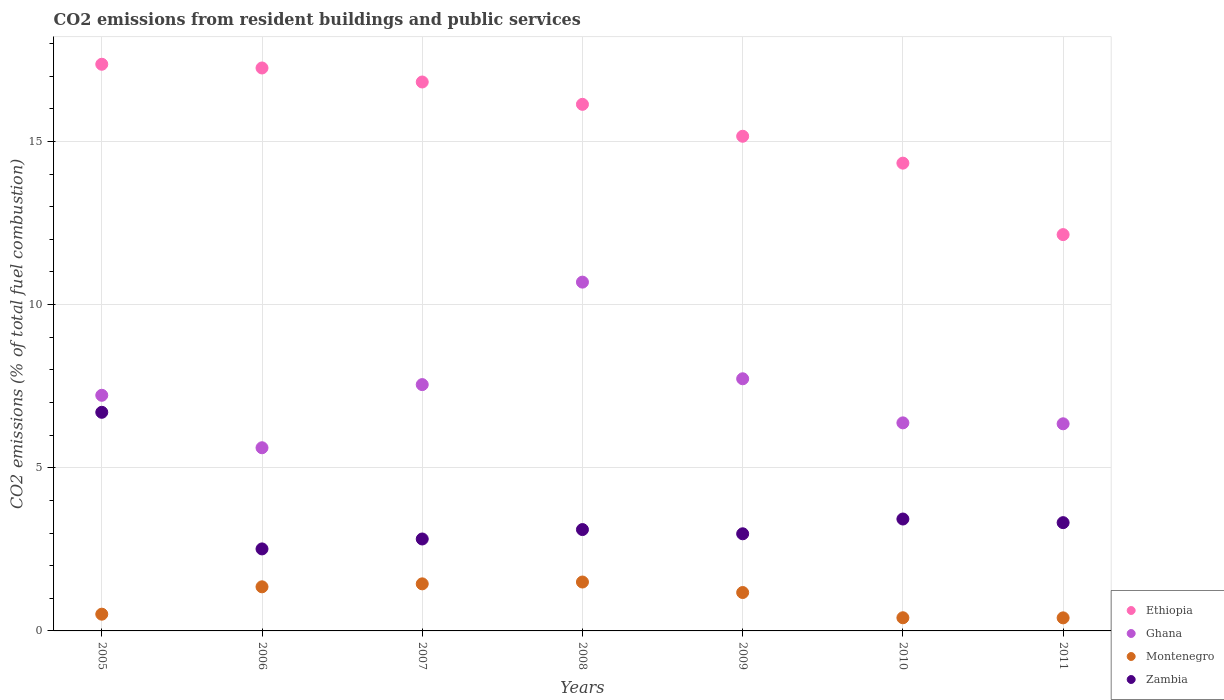How many different coloured dotlines are there?
Make the answer very short. 4. Is the number of dotlines equal to the number of legend labels?
Provide a short and direct response. Yes. What is the total CO2 emitted in Zambia in 2009?
Provide a succinct answer. 2.98. Across all years, what is the maximum total CO2 emitted in Montenegro?
Offer a terse response. 1.5. Across all years, what is the minimum total CO2 emitted in Ethiopia?
Offer a very short reply. 12.14. In which year was the total CO2 emitted in Ethiopia maximum?
Offer a very short reply. 2005. In which year was the total CO2 emitted in Ethiopia minimum?
Your answer should be very brief. 2011. What is the total total CO2 emitted in Ethiopia in the graph?
Give a very brief answer. 109.2. What is the difference between the total CO2 emitted in Ethiopia in 2005 and that in 2010?
Provide a succinct answer. 3.03. What is the difference between the total CO2 emitted in Ghana in 2008 and the total CO2 emitted in Zambia in 2007?
Offer a very short reply. 7.87. What is the average total CO2 emitted in Zambia per year?
Your response must be concise. 3.55. In the year 2007, what is the difference between the total CO2 emitted in Zambia and total CO2 emitted in Ghana?
Your answer should be compact. -4.73. What is the ratio of the total CO2 emitted in Ghana in 2008 to that in 2011?
Your answer should be very brief. 1.68. Is the total CO2 emitted in Ethiopia in 2009 less than that in 2010?
Offer a terse response. No. Is the difference between the total CO2 emitted in Zambia in 2009 and 2010 greater than the difference between the total CO2 emitted in Ghana in 2009 and 2010?
Your response must be concise. No. What is the difference between the highest and the second highest total CO2 emitted in Montenegro?
Give a very brief answer. 0.06. What is the difference between the highest and the lowest total CO2 emitted in Ghana?
Offer a terse response. 5.07. Is the sum of the total CO2 emitted in Ethiopia in 2008 and 2010 greater than the maximum total CO2 emitted in Ghana across all years?
Offer a very short reply. Yes. Is it the case that in every year, the sum of the total CO2 emitted in Zambia and total CO2 emitted in Ethiopia  is greater than the total CO2 emitted in Montenegro?
Give a very brief answer. Yes. Does the total CO2 emitted in Ghana monotonically increase over the years?
Your answer should be compact. No. Is the total CO2 emitted in Ethiopia strictly less than the total CO2 emitted in Zambia over the years?
Make the answer very short. No. How many years are there in the graph?
Keep it short and to the point. 7. Are the values on the major ticks of Y-axis written in scientific E-notation?
Give a very brief answer. No. Does the graph contain grids?
Keep it short and to the point. Yes. How many legend labels are there?
Keep it short and to the point. 4. How are the legend labels stacked?
Give a very brief answer. Vertical. What is the title of the graph?
Give a very brief answer. CO2 emissions from resident buildings and public services. Does "Israel" appear as one of the legend labels in the graph?
Your answer should be compact. No. What is the label or title of the Y-axis?
Keep it short and to the point. CO2 emissions (% of total fuel combustion). What is the CO2 emissions (% of total fuel combustion) in Ethiopia in 2005?
Ensure brevity in your answer.  17.36. What is the CO2 emissions (% of total fuel combustion) in Ghana in 2005?
Provide a succinct answer. 7.22. What is the CO2 emissions (% of total fuel combustion) in Montenegro in 2005?
Make the answer very short. 0.51. What is the CO2 emissions (% of total fuel combustion) in Zambia in 2005?
Ensure brevity in your answer.  6.7. What is the CO2 emissions (% of total fuel combustion) in Ethiopia in 2006?
Offer a terse response. 17.25. What is the CO2 emissions (% of total fuel combustion) in Ghana in 2006?
Make the answer very short. 5.61. What is the CO2 emissions (% of total fuel combustion) of Montenegro in 2006?
Provide a short and direct response. 1.35. What is the CO2 emissions (% of total fuel combustion) in Zambia in 2006?
Your response must be concise. 2.51. What is the CO2 emissions (% of total fuel combustion) of Ethiopia in 2007?
Offer a very short reply. 16.82. What is the CO2 emissions (% of total fuel combustion) in Ghana in 2007?
Your answer should be compact. 7.55. What is the CO2 emissions (% of total fuel combustion) in Montenegro in 2007?
Offer a terse response. 1.44. What is the CO2 emissions (% of total fuel combustion) of Zambia in 2007?
Provide a succinct answer. 2.82. What is the CO2 emissions (% of total fuel combustion) of Ethiopia in 2008?
Give a very brief answer. 16.13. What is the CO2 emissions (% of total fuel combustion) in Ghana in 2008?
Offer a very short reply. 10.69. What is the CO2 emissions (% of total fuel combustion) in Montenegro in 2008?
Give a very brief answer. 1.5. What is the CO2 emissions (% of total fuel combustion) in Zambia in 2008?
Give a very brief answer. 3.11. What is the CO2 emissions (% of total fuel combustion) of Ethiopia in 2009?
Provide a succinct answer. 15.16. What is the CO2 emissions (% of total fuel combustion) of Ghana in 2009?
Your answer should be compact. 7.73. What is the CO2 emissions (% of total fuel combustion) in Montenegro in 2009?
Provide a succinct answer. 1.18. What is the CO2 emissions (% of total fuel combustion) in Zambia in 2009?
Your response must be concise. 2.98. What is the CO2 emissions (% of total fuel combustion) of Ethiopia in 2010?
Keep it short and to the point. 14.33. What is the CO2 emissions (% of total fuel combustion) of Ghana in 2010?
Keep it short and to the point. 6.37. What is the CO2 emissions (% of total fuel combustion) in Montenegro in 2010?
Keep it short and to the point. 0.4. What is the CO2 emissions (% of total fuel combustion) in Zambia in 2010?
Offer a very short reply. 3.43. What is the CO2 emissions (% of total fuel combustion) of Ethiopia in 2011?
Your answer should be very brief. 12.14. What is the CO2 emissions (% of total fuel combustion) in Ghana in 2011?
Offer a terse response. 6.35. What is the CO2 emissions (% of total fuel combustion) of Zambia in 2011?
Offer a terse response. 3.32. Across all years, what is the maximum CO2 emissions (% of total fuel combustion) of Ethiopia?
Your answer should be compact. 17.36. Across all years, what is the maximum CO2 emissions (% of total fuel combustion) in Ghana?
Your answer should be very brief. 10.69. Across all years, what is the maximum CO2 emissions (% of total fuel combustion) of Montenegro?
Make the answer very short. 1.5. Across all years, what is the maximum CO2 emissions (% of total fuel combustion) in Zambia?
Provide a succinct answer. 6.7. Across all years, what is the minimum CO2 emissions (% of total fuel combustion) in Ethiopia?
Your answer should be compact. 12.14. Across all years, what is the minimum CO2 emissions (% of total fuel combustion) in Ghana?
Your answer should be very brief. 5.61. Across all years, what is the minimum CO2 emissions (% of total fuel combustion) of Montenegro?
Offer a terse response. 0.4. Across all years, what is the minimum CO2 emissions (% of total fuel combustion) of Zambia?
Offer a terse response. 2.51. What is the total CO2 emissions (% of total fuel combustion) in Ethiopia in the graph?
Your answer should be compact. 109.2. What is the total CO2 emissions (% of total fuel combustion) of Ghana in the graph?
Provide a short and direct response. 51.51. What is the total CO2 emissions (% of total fuel combustion) in Montenegro in the graph?
Your answer should be compact. 6.78. What is the total CO2 emissions (% of total fuel combustion) in Zambia in the graph?
Your response must be concise. 24.86. What is the difference between the CO2 emissions (% of total fuel combustion) of Ethiopia in 2005 and that in 2006?
Provide a short and direct response. 0.11. What is the difference between the CO2 emissions (% of total fuel combustion) of Ghana in 2005 and that in 2006?
Ensure brevity in your answer.  1.61. What is the difference between the CO2 emissions (% of total fuel combustion) of Montenegro in 2005 and that in 2006?
Make the answer very short. -0.84. What is the difference between the CO2 emissions (% of total fuel combustion) in Zambia in 2005 and that in 2006?
Offer a terse response. 4.19. What is the difference between the CO2 emissions (% of total fuel combustion) of Ethiopia in 2005 and that in 2007?
Your response must be concise. 0.54. What is the difference between the CO2 emissions (% of total fuel combustion) of Ghana in 2005 and that in 2007?
Give a very brief answer. -0.33. What is the difference between the CO2 emissions (% of total fuel combustion) in Montenegro in 2005 and that in 2007?
Provide a short and direct response. -0.93. What is the difference between the CO2 emissions (% of total fuel combustion) in Zambia in 2005 and that in 2007?
Provide a short and direct response. 3.88. What is the difference between the CO2 emissions (% of total fuel combustion) in Ethiopia in 2005 and that in 2008?
Your answer should be very brief. 1.23. What is the difference between the CO2 emissions (% of total fuel combustion) in Ghana in 2005 and that in 2008?
Your answer should be compact. -3.47. What is the difference between the CO2 emissions (% of total fuel combustion) of Montenegro in 2005 and that in 2008?
Your answer should be very brief. -0.99. What is the difference between the CO2 emissions (% of total fuel combustion) in Zambia in 2005 and that in 2008?
Offer a terse response. 3.59. What is the difference between the CO2 emissions (% of total fuel combustion) of Ethiopia in 2005 and that in 2009?
Your response must be concise. 2.21. What is the difference between the CO2 emissions (% of total fuel combustion) of Ghana in 2005 and that in 2009?
Ensure brevity in your answer.  -0.51. What is the difference between the CO2 emissions (% of total fuel combustion) of Montenegro in 2005 and that in 2009?
Provide a succinct answer. -0.66. What is the difference between the CO2 emissions (% of total fuel combustion) of Zambia in 2005 and that in 2009?
Provide a short and direct response. 3.72. What is the difference between the CO2 emissions (% of total fuel combustion) in Ethiopia in 2005 and that in 2010?
Give a very brief answer. 3.03. What is the difference between the CO2 emissions (% of total fuel combustion) of Ghana in 2005 and that in 2010?
Your response must be concise. 0.84. What is the difference between the CO2 emissions (% of total fuel combustion) in Montenegro in 2005 and that in 2010?
Offer a terse response. 0.11. What is the difference between the CO2 emissions (% of total fuel combustion) of Zambia in 2005 and that in 2010?
Provide a short and direct response. 3.27. What is the difference between the CO2 emissions (% of total fuel combustion) in Ethiopia in 2005 and that in 2011?
Provide a short and direct response. 5.22. What is the difference between the CO2 emissions (% of total fuel combustion) of Ghana in 2005 and that in 2011?
Your answer should be very brief. 0.87. What is the difference between the CO2 emissions (% of total fuel combustion) in Montenegro in 2005 and that in 2011?
Ensure brevity in your answer.  0.11. What is the difference between the CO2 emissions (% of total fuel combustion) of Zambia in 2005 and that in 2011?
Offer a terse response. 3.38. What is the difference between the CO2 emissions (% of total fuel combustion) of Ethiopia in 2006 and that in 2007?
Make the answer very short. 0.43. What is the difference between the CO2 emissions (% of total fuel combustion) in Ghana in 2006 and that in 2007?
Provide a short and direct response. -1.93. What is the difference between the CO2 emissions (% of total fuel combustion) in Montenegro in 2006 and that in 2007?
Provide a short and direct response. -0.09. What is the difference between the CO2 emissions (% of total fuel combustion) in Zambia in 2006 and that in 2007?
Your answer should be compact. -0.3. What is the difference between the CO2 emissions (% of total fuel combustion) of Ethiopia in 2006 and that in 2008?
Ensure brevity in your answer.  1.11. What is the difference between the CO2 emissions (% of total fuel combustion) in Ghana in 2006 and that in 2008?
Offer a very short reply. -5.07. What is the difference between the CO2 emissions (% of total fuel combustion) of Montenegro in 2006 and that in 2008?
Give a very brief answer. -0.15. What is the difference between the CO2 emissions (% of total fuel combustion) of Zambia in 2006 and that in 2008?
Ensure brevity in your answer.  -0.59. What is the difference between the CO2 emissions (% of total fuel combustion) of Ethiopia in 2006 and that in 2009?
Give a very brief answer. 2.09. What is the difference between the CO2 emissions (% of total fuel combustion) in Ghana in 2006 and that in 2009?
Your response must be concise. -2.11. What is the difference between the CO2 emissions (% of total fuel combustion) of Montenegro in 2006 and that in 2009?
Keep it short and to the point. 0.17. What is the difference between the CO2 emissions (% of total fuel combustion) in Zambia in 2006 and that in 2009?
Ensure brevity in your answer.  -0.46. What is the difference between the CO2 emissions (% of total fuel combustion) in Ethiopia in 2006 and that in 2010?
Keep it short and to the point. 2.92. What is the difference between the CO2 emissions (% of total fuel combustion) in Ghana in 2006 and that in 2010?
Your answer should be very brief. -0.76. What is the difference between the CO2 emissions (% of total fuel combustion) of Montenegro in 2006 and that in 2010?
Make the answer very short. 0.95. What is the difference between the CO2 emissions (% of total fuel combustion) of Zambia in 2006 and that in 2010?
Offer a very short reply. -0.92. What is the difference between the CO2 emissions (% of total fuel combustion) of Ethiopia in 2006 and that in 2011?
Make the answer very short. 5.11. What is the difference between the CO2 emissions (% of total fuel combustion) of Ghana in 2006 and that in 2011?
Offer a terse response. -0.73. What is the difference between the CO2 emissions (% of total fuel combustion) of Montenegro in 2006 and that in 2011?
Give a very brief answer. 0.95. What is the difference between the CO2 emissions (% of total fuel combustion) of Zambia in 2006 and that in 2011?
Give a very brief answer. -0.81. What is the difference between the CO2 emissions (% of total fuel combustion) in Ethiopia in 2007 and that in 2008?
Ensure brevity in your answer.  0.68. What is the difference between the CO2 emissions (% of total fuel combustion) in Ghana in 2007 and that in 2008?
Give a very brief answer. -3.14. What is the difference between the CO2 emissions (% of total fuel combustion) in Montenegro in 2007 and that in 2008?
Keep it short and to the point. -0.06. What is the difference between the CO2 emissions (% of total fuel combustion) in Zambia in 2007 and that in 2008?
Provide a short and direct response. -0.29. What is the difference between the CO2 emissions (% of total fuel combustion) of Ethiopia in 2007 and that in 2009?
Give a very brief answer. 1.66. What is the difference between the CO2 emissions (% of total fuel combustion) in Ghana in 2007 and that in 2009?
Your response must be concise. -0.18. What is the difference between the CO2 emissions (% of total fuel combustion) of Montenegro in 2007 and that in 2009?
Ensure brevity in your answer.  0.27. What is the difference between the CO2 emissions (% of total fuel combustion) in Zambia in 2007 and that in 2009?
Keep it short and to the point. -0.16. What is the difference between the CO2 emissions (% of total fuel combustion) in Ethiopia in 2007 and that in 2010?
Give a very brief answer. 2.49. What is the difference between the CO2 emissions (% of total fuel combustion) of Ghana in 2007 and that in 2010?
Offer a very short reply. 1.17. What is the difference between the CO2 emissions (% of total fuel combustion) of Montenegro in 2007 and that in 2010?
Offer a very short reply. 1.04. What is the difference between the CO2 emissions (% of total fuel combustion) of Zambia in 2007 and that in 2010?
Keep it short and to the point. -0.61. What is the difference between the CO2 emissions (% of total fuel combustion) in Ethiopia in 2007 and that in 2011?
Offer a very short reply. 4.68. What is the difference between the CO2 emissions (% of total fuel combustion) of Ghana in 2007 and that in 2011?
Your response must be concise. 1.2. What is the difference between the CO2 emissions (% of total fuel combustion) of Montenegro in 2007 and that in 2011?
Your response must be concise. 1.04. What is the difference between the CO2 emissions (% of total fuel combustion) in Zambia in 2007 and that in 2011?
Ensure brevity in your answer.  -0.5. What is the difference between the CO2 emissions (% of total fuel combustion) in Ethiopia in 2008 and that in 2009?
Your response must be concise. 0.98. What is the difference between the CO2 emissions (% of total fuel combustion) in Ghana in 2008 and that in 2009?
Your response must be concise. 2.96. What is the difference between the CO2 emissions (% of total fuel combustion) in Montenegro in 2008 and that in 2009?
Your response must be concise. 0.32. What is the difference between the CO2 emissions (% of total fuel combustion) of Zambia in 2008 and that in 2009?
Your answer should be compact. 0.13. What is the difference between the CO2 emissions (% of total fuel combustion) of Ethiopia in 2008 and that in 2010?
Offer a very short reply. 1.8. What is the difference between the CO2 emissions (% of total fuel combustion) in Ghana in 2008 and that in 2010?
Offer a terse response. 4.31. What is the difference between the CO2 emissions (% of total fuel combustion) of Montenegro in 2008 and that in 2010?
Offer a terse response. 1.09. What is the difference between the CO2 emissions (% of total fuel combustion) in Zambia in 2008 and that in 2010?
Your response must be concise. -0.32. What is the difference between the CO2 emissions (% of total fuel combustion) in Ethiopia in 2008 and that in 2011?
Offer a terse response. 3.99. What is the difference between the CO2 emissions (% of total fuel combustion) in Ghana in 2008 and that in 2011?
Your answer should be very brief. 4.34. What is the difference between the CO2 emissions (% of total fuel combustion) of Montenegro in 2008 and that in 2011?
Your answer should be compact. 1.1. What is the difference between the CO2 emissions (% of total fuel combustion) in Zambia in 2008 and that in 2011?
Provide a succinct answer. -0.21. What is the difference between the CO2 emissions (% of total fuel combustion) of Ethiopia in 2009 and that in 2010?
Your answer should be very brief. 0.82. What is the difference between the CO2 emissions (% of total fuel combustion) in Ghana in 2009 and that in 2010?
Your answer should be compact. 1.35. What is the difference between the CO2 emissions (% of total fuel combustion) of Montenegro in 2009 and that in 2010?
Offer a terse response. 0.77. What is the difference between the CO2 emissions (% of total fuel combustion) in Zambia in 2009 and that in 2010?
Give a very brief answer. -0.45. What is the difference between the CO2 emissions (% of total fuel combustion) of Ethiopia in 2009 and that in 2011?
Provide a succinct answer. 3.01. What is the difference between the CO2 emissions (% of total fuel combustion) of Ghana in 2009 and that in 2011?
Your answer should be compact. 1.38. What is the difference between the CO2 emissions (% of total fuel combustion) in Montenegro in 2009 and that in 2011?
Offer a terse response. 0.78. What is the difference between the CO2 emissions (% of total fuel combustion) of Zambia in 2009 and that in 2011?
Keep it short and to the point. -0.34. What is the difference between the CO2 emissions (% of total fuel combustion) of Ethiopia in 2010 and that in 2011?
Offer a very short reply. 2.19. What is the difference between the CO2 emissions (% of total fuel combustion) in Ghana in 2010 and that in 2011?
Make the answer very short. 0.03. What is the difference between the CO2 emissions (% of total fuel combustion) in Montenegro in 2010 and that in 2011?
Offer a very short reply. 0. What is the difference between the CO2 emissions (% of total fuel combustion) in Zambia in 2010 and that in 2011?
Give a very brief answer. 0.11. What is the difference between the CO2 emissions (% of total fuel combustion) in Ethiopia in 2005 and the CO2 emissions (% of total fuel combustion) in Ghana in 2006?
Offer a terse response. 11.75. What is the difference between the CO2 emissions (% of total fuel combustion) in Ethiopia in 2005 and the CO2 emissions (% of total fuel combustion) in Montenegro in 2006?
Offer a terse response. 16.01. What is the difference between the CO2 emissions (% of total fuel combustion) in Ethiopia in 2005 and the CO2 emissions (% of total fuel combustion) in Zambia in 2006?
Offer a terse response. 14.85. What is the difference between the CO2 emissions (% of total fuel combustion) of Ghana in 2005 and the CO2 emissions (% of total fuel combustion) of Montenegro in 2006?
Provide a succinct answer. 5.87. What is the difference between the CO2 emissions (% of total fuel combustion) of Ghana in 2005 and the CO2 emissions (% of total fuel combustion) of Zambia in 2006?
Offer a terse response. 4.71. What is the difference between the CO2 emissions (% of total fuel combustion) in Montenegro in 2005 and the CO2 emissions (% of total fuel combustion) in Zambia in 2006?
Give a very brief answer. -2. What is the difference between the CO2 emissions (% of total fuel combustion) of Ethiopia in 2005 and the CO2 emissions (% of total fuel combustion) of Ghana in 2007?
Offer a very short reply. 9.82. What is the difference between the CO2 emissions (% of total fuel combustion) of Ethiopia in 2005 and the CO2 emissions (% of total fuel combustion) of Montenegro in 2007?
Offer a terse response. 15.92. What is the difference between the CO2 emissions (% of total fuel combustion) in Ethiopia in 2005 and the CO2 emissions (% of total fuel combustion) in Zambia in 2007?
Your answer should be compact. 14.55. What is the difference between the CO2 emissions (% of total fuel combustion) in Ghana in 2005 and the CO2 emissions (% of total fuel combustion) in Montenegro in 2007?
Your answer should be compact. 5.78. What is the difference between the CO2 emissions (% of total fuel combustion) in Ghana in 2005 and the CO2 emissions (% of total fuel combustion) in Zambia in 2007?
Provide a short and direct response. 4.4. What is the difference between the CO2 emissions (% of total fuel combustion) in Montenegro in 2005 and the CO2 emissions (% of total fuel combustion) in Zambia in 2007?
Your answer should be compact. -2.3. What is the difference between the CO2 emissions (% of total fuel combustion) in Ethiopia in 2005 and the CO2 emissions (% of total fuel combustion) in Ghana in 2008?
Offer a terse response. 6.68. What is the difference between the CO2 emissions (% of total fuel combustion) of Ethiopia in 2005 and the CO2 emissions (% of total fuel combustion) of Montenegro in 2008?
Offer a terse response. 15.86. What is the difference between the CO2 emissions (% of total fuel combustion) in Ethiopia in 2005 and the CO2 emissions (% of total fuel combustion) in Zambia in 2008?
Keep it short and to the point. 14.26. What is the difference between the CO2 emissions (% of total fuel combustion) in Ghana in 2005 and the CO2 emissions (% of total fuel combustion) in Montenegro in 2008?
Offer a very short reply. 5.72. What is the difference between the CO2 emissions (% of total fuel combustion) of Ghana in 2005 and the CO2 emissions (% of total fuel combustion) of Zambia in 2008?
Your answer should be compact. 4.11. What is the difference between the CO2 emissions (% of total fuel combustion) in Montenegro in 2005 and the CO2 emissions (% of total fuel combustion) in Zambia in 2008?
Offer a terse response. -2.59. What is the difference between the CO2 emissions (% of total fuel combustion) in Ethiopia in 2005 and the CO2 emissions (% of total fuel combustion) in Ghana in 2009?
Your response must be concise. 9.64. What is the difference between the CO2 emissions (% of total fuel combustion) in Ethiopia in 2005 and the CO2 emissions (% of total fuel combustion) in Montenegro in 2009?
Your answer should be very brief. 16.19. What is the difference between the CO2 emissions (% of total fuel combustion) in Ethiopia in 2005 and the CO2 emissions (% of total fuel combustion) in Zambia in 2009?
Offer a terse response. 14.39. What is the difference between the CO2 emissions (% of total fuel combustion) of Ghana in 2005 and the CO2 emissions (% of total fuel combustion) of Montenegro in 2009?
Your response must be concise. 6.04. What is the difference between the CO2 emissions (% of total fuel combustion) in Ghana in 2005 and the CO2 emissions (% of total fuel combustion) in Zambia in 2009?
Provide a short and direct response. 4.24. What is the difference between the CO2 emissions (% of total fuel combustion) in Montenegro in 2005 and the CO2 emissions (% of total fuel combustion) in Zambia in 2009?
Provide a succinct answer. -2.46. What is the difference between the CO2 emissions (% of total fuel combustion) in Ethiopia in 2005 and the CO2 emissions (% of total fuel combustion) in Ghana in 2010?
Offer a very short reply. 10.99. What is the difference between the CO2 emissions (% of total fuel combustion) of Ethiopia in 2005 and the CO2 emissions (% of total fuel combustion) of Montenegro in 2010?
Provide a succinct answer. 16.96. What is the difference between the CO2 emissions (% of total fuel combustion) in Ethiopia in 2005 and the CO2 emissions (% of total fuel combustion) in Zambia in 2010?
Make the answer very short. 13.93. What is the difference between the CO2 emissions (% of total fuel combustion) in Ghana in 2005 and the CO2 emissions (% of total fuel combustion) in Montenegro in 2010?
Offer a terse response. 6.82. What is the difference between the CO2 emissions (% of total fuel combustion) of Ghana in 2005 and the CO2 emissions (% of total fuel combustion) of Zambia in 2010?
Offer a very short reply. 3.79. What is the difference between the CO2 emissions (% of total fuel combustion) in Montenegro in 2005 and the CO2 emissions (% of total fuel combustion) in Zambia in 2010?
Offer a terse response. -2.92. What is the difference between the CO2 emissions (% of total fuel combustion) in Ethiopia in 2005 and the CO2 emissions (% of total fuel combustion) in Ghana in 2011?
Your answer should be very brief. 11.02. What is the difference between the CO2 emissions (% of total fuel combustion) in Ethiopia in 2005 and the CO2 emissions (% of total fuel combustion) in Montenegro in 2011?
Provide a short and direct response. 16.96. What is the difference between the CO2 emissions (% of total fuel combustion) in Ethiopia in 2005 and the CO2 emissions (% of total fuel combustion) in Zambia in 2011?
Make the answer very short. 14.05. What is the difference between the CO2 emissions (% of total fuel combustion) in Ghana in 2005 and the CO2 emissions (% of total fuel combustion) in Montenegro in 2011?
Make the answer very short. 6.82. What is the difference between the CO2 emissions (% of total fuel combustion) in Ghana in 2005 and the CO2 emissions (% of total fuel combustion) in Zambia in 2011?
Your response must be concise. 3.9. What is the difference between the CO2 emissions (% of total fuel combustion) in Montenegro in 2005 and the CO2 emissions (% of total fuel combustion) in Zambia in 2011?
Ensure brevity in your answer.  -2.8. What is the difference between the CO2 emissions (% of total fuel combustion) of Ethiopia in 2006 and the CO2 emissions (% of total fuel combustion) of Ghana in 2007?
Offer a very short reply. 9.7. What is the difference between the CO2 emissions (% of total fuel combustion) in Ethiopia in 2006 and the CO2 emissions (% of total fuel combustion) in Montenegro in 2007?
Keep it short and to the point. 15.81. What is the difference between the CO2 emissions (% of total fuel combustion) of Ethiopia in 2006 and the CO2 emissions (% of total fuel combustion) of Zambia in 2007?
Keep it short and to the point. 14.43. What is the difference between the CO2 emissions (% of total fuel combustion) in Ghana in 2006 and the CO2 emissions (% of total fuel combustion) in Montenegro in 2007?
Ensure brevity in your answer.  4.17. What is the difference between the CO2 emissions (% of total fuel combustion) of Ghana in 2006 and the CO2 emissions (% of total fuel combustion) of Zambia in 2007?
Keep it short and to the point. 2.8. What is the difference between the CO2 emissions (% of total fuel combustion) of Montenegro in 2006 and the CO2 emissions (% of total fuel combustion) of Zambia in 2007?
Your response must be concise. -1.47. What is the difference between the CO2 emissions (% of total fuel combustion) of Ethiopia in 2006 and the CO2 emissions (% of total fuel combustion) of Ghana in 2008?
Offer a very short reply. 6.56. What is the difference between the CO2 emissions (% of total fuel combustion) of Ethiopia in 2006 and the CO2 emissions (% of total fuel combustion) of Montenegro in 2008?
Keep it short and to the point. 15.75. What is the difference between the CO2 emissions (% of total fuel combustion) of Ethiopia in 2006 and the CO2 emissions (% of total fuel combustion) of Zambia in 2008?
Ensure brevity in your answer.  14.14. What is the difference between the CO2 emissions (% of total fuel combustion) of Ghana in 2006 and the CO2 emissions (% of total fuel combustion) of Montenegro in 2008?
Your answer should be very brief. 4.11. What is the difference between the CO2 emissions (% of total fuel combustion) of Ghana in 2006 and the CO2 emissions (% of total fuel combustion) of Zambia in 2008?
Your answer should be compact. 2.51. What is the difference between the CO2 emissions (% of total fuel combustion) in Montenegro in 2006 and the CO2 emissions (% of total fuel combustion) in Zambia in 2008?
Make the answer very short. -1.75. What is the difference between the CO2 emissions (% of total fuel combustion) of Ethiopia in 2006 and the CO2 emissions (% of total fuel combustion) of Ghana in 2009?
Offer a very short reply. 9.52. What is the difference between the CO2 emissions (% of total fuel combustion) in Ethiopia in 2006 and the CO2 emissions (% of total fuel combustion) in Montenegro in 2009?
Keep it short and to the point. 16.07. What is the difference between the CO2 emissions (% of total fuel combustion) of Ethiopia in 2006 and the CO2 emissions (% of total fuel combustion) of Zambia in 2009?
Give a very brief answer. 14.27. What is the difference between the CO2 emissions (% of total fuel combustion) in Ghana in 2006 and the CO2 emissions (% of total fuel combustion) in Montenegro in 2009?
Ensure brevity in your answer.  4.44. What is the difference between the CO2 emissions (% of total fuel combustion) in Ghana in 2006 and the CO2 emissions (% of total fuel combustion) in Zambia in 2009?
Provide a short and direct response. 2.64. What is the difference between the CO2 emissions (% of total fuel combustion) of Montenegro in 2006 and the CO2 emissions (% of total fuel combustion) of Zambia in 2009?
Provide a short and direct response. -1.62. What is the difference between the CO2 emissions (% of total fuel combustion) of Ethiopia in 2006 and the CO2 emissions (% of total fuel combustion) of Ghana in 2010?
Your answer should be compact. 10.87. What is the difference between the CO2 emissions (% of total fuel combustion) of Ethiopia in 2006 and the CO2 emissions (% of total fuel combustion) of Montenegro in 2010?
Ensure brevity in your answer.  16.85. What is the difference between the CO2 emissions (% of total fuel combustion) of Ethiopia in 2006 and the CO2 emissions (% of total fuel combustion) of Zambia in 2010?
Provide a short and direct response. 13.82. What is the difference between the CO2 emissions (% of total fuel combustion) in Ghana in 2006 and the CO2 emissions (% of total fuel combustion) in Montenegro in 2010?
Provide a short and direct response. 5.21. What is the difference between the CO2 emissions (% of total fuel combustion) in Ghana in 2006 and the CO2 emissions (% of total fuel combustion) in Zambia in 2010?
Your response must be concise. 2.18. What is the difference between the CO2 emissions (% of total fuel combustion) in Montenegro in 2006 and the CO2 emissions (% of total fuel combustion) in Zambia in 2010?
Your answer should be very brief. -2.08. What is the difference between the CO2 emissions (% of total fuel combustion) of Ethiopia in 2006 and the CO2 emissions (% of total fuel combustion) of Ghana in 2011?
Provide a short and direct response. 10.9. What is the difference between the CO2 emissions (% of total fuel combustion) of Ethiopia in 2006 and the CO2 emissions (% of total fuel combustion) of Montenegro in 2011?
Offer a very short reply. 16.85. What is the difference between the CO2 emissions (% of total fuel combustion) of Ethiopia in 2006 and the CO2 emissions (% of total fuel combustion) of Zambia in 2011?
Provide a short and direct response. 13.93. What is the difference between the CO2 emissions (% of total fuel combustion) of Ghana in 2006 and the CO2 emissions (% of total fuel combustion) of Montenegro in 2011?
Your answer should be very brief. 5.21. What is the difference between the CO2 emissions (% of total fuel combustion) of Ghana in 2006 and the CO2 emissions (% of total fuel combustion) of Zambia in 2011?
Give a very brief answer. 2.29. What is the difference between the CO2 emissions (% of total fuel combustion) of Montenegro in 2006 and the CO2 emissions (% of total fuel combustion) of Zambia in 2011?
Ensure brevity in your answer.  -1.97. What is the difference between the CO2 emissions (% of total fuel combustion) in Ethiopia in 2007 and the CO2 emissions (% of total fuel combustion) in Ghana in 2008?
Your answer should be very brief. 6.13. What is the difference between the CO2 emissions (% of total fuel combustion) in Ethiopia in 2007 and the CO2 emissions (% of total fuel combustion) in Montenegro in 2008?
Your answer should be very brief. 15.32. What is the difference between the CO2 emissions (% of total fuel combustion) in Ethiopia in 2007 and the CO2 emissions (% of total fuel combustion) in Zambia in 2008?
Your answer should be very brief. 13.71. What is the difference between the CO2 emissions (% of total fuel combustion) of Ghana in 2007 and the CO2 emissions (% of total fuel combustion) of Montenegro in 2008?
Make the answer very short. 6.05. What is the difference between the CO2 emissions (% of total fuel combustion) of Ghana in 2007 and the CO2 emissions (% of total fuel combustion) of Zambia in 2008?
Provide a short and direct response. 4.44. What is the difference between the CO2 emissions (% of total fuel combustion) in Montenegro in 2007 and the CO2 emissions (% of total fuel combustion) in Zambia in 2008?
Your response must be concise. -1.66. What is the difference between the CO2 emissions (% of total fuel combustion) in Ethiopia in 2007 and the CO2 emissions (% of total fuel combustion) in Ghana in 2009?
Give a very brief answer. 9.09. What is the difference between the CO2 emissions (% of total fuel combustion) in Ethiopia in 2007 and the CO2 emissions (% of total fuel combustion) in Montenegro in 2009?
Your response must be concise. 15.64. What is the difference between the CO2 emissions (% of total fuel combustion) in Ethiopia in 2007 and the CO2 emissions (% of total fuel combustion) in Zambia in 2009?
Provide a succinct answer. 13.84. What is the difference between the CO2 emissions (% of total fuel combustion) in Ghana in 2007 and the CO2 emissions (% of total fuel combustion) in Montenegro in 2009?
Your answer should be compact. 6.37. What is the difference between the CO2 emissions (% of total fuel combustion) in Ghana in 2007 and the CO2 emissions (% of total fuel combustion) in Zambia in 2009?
Provide a succinct answer. 4.57. What is the difference between the CO2 emissions (% of total fuel combustion) of Montenegro in 2007 and the CO2 emissions (% of total fuel combustion) of Zambia in 2009?
Make the answer very short. -1.53. What is the difference between the CO2 emissions (% of total fuel combustion) of Ethiopia in 2007 and the CO2 emissions (% of total fuel combustion) of Ghana in 2010?
Ensure brevity in your answer.  10.44. What is the difference between the CO2 emissions (% of total fuel combustion) of Ethiopia in 2007 and the CO2 emissions (% of total fuel combustion) of Montenegro in 2010?
Offer a very short reply. 16.42. What is the difference between the CO2 emissions (% of total fuel combustion) of Ethiopia in 2007 and the CO2 emissions (% of total fuel combustion) of Zambia in 2010?
Offer a terse response. 13.39. What is the difference between the CO2 emissions (% of total fuel combustion) of Ghana in 2007 and the CO2 emissions (% of total fuel combustion) of Montenegro in 2010?
Your answer should be compact. 7.14. What is the difference between the CO2 emissions (% of total fuel combustion) in Ghana in 2007 and the CO2 emissions (% of total fuel combustion) in Zambia in 2010?
Provide a short and direct response. 4.12. What is the difference between the CO2 emissions (% of total fuel combustion) in Montenegro in 2007 and the CO2 emissions (% of total fuel combustion) in Zambia in 2010?
Your response must be concise. -1.99. What is the difference between the CO2 emissions (% of total fuel combustion) in Ethiopia in 2007 and the CO2 emissions (% of total fuel combustion) in Ghana in 2011?
Provide a succinct answer. 10.47. What is the difference between the CO2 emissions (% of total fuel combustion) in Ethiopia in 2007 and the CO2 emissions (% of total fuel combustion) in Montenegro in 2011?
Make the answer very short. 16.42. What is the difference between the CO2 emissions (% of total fuel combustion) of Ethiopia in 2007 and the CO2 emissions (% of total fuel combustion) of Zambia in 2011?
Provide a succinct answer. 13.5. What is the difference between the CO2 emissions (% of total fuel combustion) of Ghana in 2007 and the CO2 emissions (% of total fuel combustion) of Montenegro in 2011?
Ensure brevity in your answer.  7.15. What is the difference between the CO2 emissions (% of total fuel combustion) of Ghana in 2007 and the CO2 emissions (% of total fuel combustion) of Zambia in 2011?
Give a very brief answer. 4.23. What is the difference between the CO2 emissions (% of total fuel combustion) of Montenegro in 2007 and the CO2 emissions (% of total fuel combustion) of Zambia in 2011?
Offer a very short reply. -1.88. What is the difference between the CO2 emissions (% of total fuel combustion) of Ethiopia in 2008 and the CO2 emissions (% of total fuel combustion) of Ghana in 2009?
Provide a short and direct response. 8.41. What is the difference between the CO2 emissions (% of total fuel combustion) of Ethiopia in 2008 and the CO2 emissions (% of total fuel combustion) of Montenegro in 2009?
Your answer should be very brief. 14.96. What is the difference between the CO2 emissions (% of total fuel combustion) in Ethiopia in 2008 and the CO2 emissions (% of total fuel combustion) in Zambia in 2009?
Offer a terse response. 13.16. What is the difference between the CO2 emissions (% of total fuel combustion) of Ghana in 2008 and the CO2 emissions (% of total fuel combustion) of Montenegro in 2009?
Offer a very short reply. 9.51. What is the difference between the CO2 emissions (% of total fuel combustion) of Ghana in 2008 and the CO2 emissions (% of total fuel combustion) of Zambia in 2009?
Your response must be concise. 7.71. What is the difference between the CO2 emissions (% of total fuel combustion) of Montenegro in 2008 and the CO2 emissions (% of total fuel combustion) of Zambia in 2009?
Provide a succinct answer. -1.48. What is the difference between the CO2 emissions (% of total fuel combustion) of Ethiopia in 2008 and the CO2 emissions (% of total fuel combustion) of Ghana in 2010?
Give a very brief answer. 9.76. What is the difference between the CO2 emissions (% of total fuel combustion) in Ethiopia in 2008 and the CO2 emissions (% of total fuel combustion) in Montenegro in 2010?
Your response must be concise. 15.73. What is the difference between the CO2 emissions (% of total fuel combustion) in Ethiopia in 2008 and the CO2 emissions (% of total fuel combustion) in Zambia in 2010?
Your answer should be very brief. 12.71. What is the difference between the CO2 emissions (% of total fuel combustion) of Ghana in 2008 and the CO2 emissions (% of total fuel combustion) of Montenegro in 2010?
Give a very brief answer. 10.28. What is the difference between the CO2 emissions (% of total fuel combustion) in Ghana in 2008 and the CO2 emissions (% of total fuel combustion) in Zambia in 2010?
Keep it short and to the point. 7.26. What is the difference between the CO2 emissions (% of total fuel combustion) in Montenegro in 2008 and the CO2 emissions (% of total fuel combustion) in Zambia in 2010?
Your response must be concise. -1.93. What is the difference between the CO2 emissions (% of total fuel combustion) of Ethiopia in 2008 and the CO2 emissions (% of total fuel combustion) of Ghana in 2011?
Give a very brief answer. 9.79. What is the difference between the CO2 emissions (% of total fuel combustion) of Ethiopia in 2008 and the CO2 emissions (% of total fuel combustion) of Montenegro in 2011?
Your answer should be very brief. 15.73. What is the difference between the CO2 emissions (% of total fuel combustion) in Ethiopia in 2008 and the CO2 emissions (% of total fuel combustion) in Zambia in 2011?
Your response must be concise. 12.82. What is the difference between the CO2 emissions (% of total fuel combustion) of Ghana in 2008 and the CO2 emissions (% of total fuel combustion) of Montenegro in 2011?
Offer a terse response. 10.29. What is the difference between the CO2 emissions (% of total fuel combustion) of Ghana in 2008 and the CO2 emissions (% of total fuel combustion) of Zambia in 2011?
Offer a terse response. 7.37. What is the difference between the CO2 emissions (% of total fuel combustion) in Montenegro in 2008 and the CO2 emissions (% of total fuel combustion) in Zambia in 2011?
Provide a short and direct response. -1.82. What is the difference between the CO2 emissions (% of total fuel combustion) of Ethiopia in 2009 and the CO2 emissions (% of total fuel combustion) of Ghana in 2010?
Give a very brief answer. 8.78. What is the difference between the CO2 emissions (% of total fuel combustion) of Ethiopia in 2009 and the CO2 emissions (% of total fuel combustion) of Montenegro in 2010?
Provide a succinct answer. 14.75. What is the difference between the CO2 emissions (% of total fuel combustion) of Ethiopia in 2009 and the CO2 emissions (% of total fuel combustion) of Zambia in 2010?
Your answer should be very brief. 11.73. What is the difference between the CO2 emissions (% of total fuel combustion) in Ghana in 2009 and the CO2 emissions (% of total fuel combustion) in Montenegro in 2010?
Your answer should be very brief. 7.32. What is the difference between the CO2 emissions (% of total fuel combustion) in Ghana in 2009 and the CO2 emissions (% of total fuel combustion) in Zambia in 2010?
Ensure brevity in your answer.  4.3. What is the difference between the CO2 emissions (% of total fuel combustion) in Montenegro in 2009 and the CO2 emissions (% of total fuel combustion) in Zambia in 2010?
Keep it short and to the point. -2.25. What is the difference between the CO2 emissions (% of total fuel combustion) in Ethiopia in 2009 and the CO2 emissions (% of total fuel combustion) in Ghana in 2011?
Your response must be concise. 8.81. What is the difference between the CO2 emissions (% of total fuel combustion) of Ethiopia in 2009 and the CO2 emissions (% of total fuel combustion) of Montenegro in 2011?
Offer a very short reply. 14.76. What is the difference between the CO2 emissions (% of total fuel combustion) of Ethiopia in 2009 and the CO2 emissions (% of total fuel combustion) of Zambia in 2011?
Your response must be concise. 11.84. What is the difference between the CO2 emissions (% of total fuel combustion) of Ghana in 2009 and the CO2 emissions (% of total fuel combustion) of Montenegro in 2011?
Keep it short and to the point. 7.33. What is the difference between the CO2 emissions (% of total fuel combustion) of Ghana in 2009 and the CO2 emissions (% of total fuel combustion) of Zambia in 2011?
Make the answer very short. 4.41. What is the difference between the CO2 emissions (% of total fuel combustion) of Montenegro in 2009 and the CO2 emissions (% of total fuel combustion) of Zambia in 2011?
Keep it short and to the point. -2.14. What is the difference between the CO2 emissions (% of total fuel combustion) of Ethiopia in 2010 and the CO2 emissions (% of total fuel combustion) of Ghana in 2011?
Make the answer very short. 7.99. What is the difference between the CO2 emissions (% of total fuel combustion) in Ethiopia in 2010 and the CO2 emissions (% of total fuel combustion) in Montenegro in 2011?
Provide a short and direct response. 13.93. What is the difference between the CO2 emissions (% of total fuel combustion) in Ethiopia in 2010 and the CO2 emissions (% of total fuel combustion) in Zambia in 2011?
Ensure brevity in your answer.  11.02. What is the difference between the CO2 emissions (% of total fuel combustion) of Ghana in 2010 and the CO2 emissions (% of total fuel combustion) of Montenegro in 2011?
Keep it short and to the point. 5.97. What is the difference between the CO2 emissions (% of total fuel combustion) in Ghana in 2010 and the CO2 emissions (% of total fuel combustion) in Zambia in 2011?
Ensure brevity in your answer.  3.06. What is the difference between the CO2 emissions (% of total fuel combustion) of Montenegro in 2010 and the CO2 emissions (% of total fuel combustion) of Zambia in 2011?
Offer a terse response. -2.91. What is the average CO2 emissions (% of total fuel combustion) in Ethiopia per year?
Your response must be concise. 15.6. What is the average CO2 emissions (% of total fuel combustion) of Ghana per year?
Your answer should be very brief. 7.36. What is the average CO2 emissions (% of total fuel combustion) in Montenegro per year?
Ensure brevity in your answer.  0.97. What is the average CO2 emissions (% of total fuel combustion) of Zambia per year?
Make the answer very short. 3.55. In the year 2005, what is the difference between the CO2 emissions (% of total fuel combustion) of Ethiopia and CO2 emissions (% of total fuel combustion) of Ghana?
Offer a very short reply. 10.14. In the year 2005, what is the difference between the CO2 emissions (% of total fuel combustion) of Ethiopia and CO2 emissions (% of total fuel combustion) of Montenegro?
Provide a short and direct response. 16.85. In the year 2005, what is the difference between the CO2 emissions (% of total fuel combustion) of Ethiopia and CO2 emissions (% of total fuel combustion) of Zambia?
Make the answer very short. 10.66. In the year 2005, what is the difference between the CO2 emissions (% of total fuel combustion) of Ghana and CO2 emissions (% of total fuel combustion) of Montenegro?
Your answer should be very brief. 6.71. In the year 2005, what is the difference between the CO2 emissions (% of total fuel combustion) in Ghana and CO2 emissions (% of total fuel combustion) in Zambia?
Your response must be concise. 0.52. In the year 2005, what is the difference between the CO2 emissions (% of total fuel combustion) in Montenegro and CO2 emissions (% of total fuel combustion) in Zambia?
Offer a terse response. -6.19. In the year 2006, what is the difference between the CO2 emissions (% of total fuel combustion) of Ethiopia and CO2 emissions (% of total fuel combustion) of Ghana?
Make the answer very short. 11.64. In the year 2006, what is the difference between the CO2 emissions (% of total fuel combustion) of Ethiopia and CO2 emissions (% of total fuel combustion) of Montenegro?
Your answer should be compact. 15.9. In the year 2006, what is the difference between the CO2 emissions (% of total fuel combustion) in Ethiopia and CO2 emissions (% of total fuel combustion) in Zambia?
Offer a very short reply. 14.74. In the year 2006, what is the difference between the CO2 emissions (% of total fuel combustion) in Ghana and CO2 emissions (% of total fuel combustion) in Montenegro?
Your answer should be very brief. 4.26. In the year 2006, what is the difference between the CO2 emissions (% of total fuel combustion) in Ghana and CO2 emissions (% of total fuel combustion) in Zambia?
Provide a succinct answer. 3.1. In the year 2006, what is the difference between the CO2 emissions (% of total fuel combustion) of Montenegro and CO2 emissions (% of total fuel combustion) of Zambia?
Your answer should be compact. -1.16. In the year 2007, what is the difference between the CO2 emissions (% of total fuel combustion) in Ethiopia and CO2 emissions (% of total fuel combustion) in Ghana?
Offer a terse response. 9.27. In the year 2007, what is the difference between the CO2 emissions (% of total fuel combustion) of Ethiopia and CO2 emissions (% of total fuel combustion) of Montenegro?
Your answer should be compact. 15.38. In the year 2007, what is the difference between the CO2 emissions (% of total fuel combustion) of Ethiopia and CO2 emissions (% of total fuel combustion) of Zambia?
Provide a short and direct response. 14. In the year 2007, what is the difference between the CO2 emissions (% of total fuel combustion) of Ghana and CO2 emissions (% of total fuel combustion) of Montenegro?
Ensure brevity in your answer.  6.1. In the year 2007, what is the difference between the CO2 emissions (% of total fuel combustion) in Ghana and CO2 emissions (% of total fuel combustion) in Zambia?
Give a very brief answer. 4.73. In the year 2007, what is the difference between the CO2 emissions (% of total fuel combustion) in Montenegro and CO2 emissions (% of total fuel combustion) in Zambia?
Ensure brevity in your answer.  -1.37. In the year 2008, what is the difference between the CO2 emissions (% of total fuel combustion) of Ethiopia and CO2 emissions (% of total fuel combustion) of Ghana?
Your response must be concise. 5.45. In the year 2008, what is the difference between the CO2 emissions (% of total fuel combustion) in Ethiopia and CO2 emissions (% of total fuel combustion) in Montenegro?
Make the answer very short. 14.64. In the year 2008, what is the difference between the CO2 emissions (% of total fuel combustion) in Ethiopia and CO2 emissions (% of total fuel combustion) in Zambia?
Give a very brief answer. 13.03. In the year 2008, what is the difference between the CO2 emissions (% of total fuel combustion) in Ghana and CO2 emissions (% of total fuel combustion) in Montenegro?
Give a very brief answer. 9.19. In the year 2008, what is the difference between the CO2 emissions (% of total fuel combustion) in Ghana and CO2 emissions (% of total fuel combustion) in Zambia?
Make the answer very short. 7.58. In the year 2008, what is the difference between the CO2 emissions (% of total fuel combustion) in Montenegro and CO2 emissions (% of total fuel combustion) in Zambia?
Ensure brevity in your answer.  -1.61. In the year 2009, what is the difference between the CO2 emissions (% of total fuel combustion) of Ethiopia and CO2 emissions (% of total fuel combustion) of Ghana?
Your answer should be very brief. 7.43. In the year 2009, what is the difference between the CO2 emissions (% of total fuel combustion) in Ethiopia and CO2 emissions (% of total fuel combustion) in Montenegro?
Offer a terse response. 13.98. In the year 2009, what is the difference between the CO2 emissions (% of total fuel combustion) in Ethiopia and CO2 emissions (% of total fuel combustion) in Zambia?
Provide a succinct answer. 12.18. In the year 2009, what is the difference between the CO2 emissions (% of total fuel combustion) in Ghana and CO2 emissions (% of total fuel combustion) in Montenegro?
Provide a short and direct response. 6.55. In the year 2009, what is the difference between the CO2 emissions (% of total fuel combustion) of Ghana and CO2 emissions (% of total fuel combustion) of Zambia?
Keep it short and to the point. 4.75. In the year 2009, what is the difference between the CO2 emissions (% of total fuel combustion) of Montenegro and CO2 emissions (% of total fuel combustion) of Zambia?
Your response must be concise. -1.8. In the year 2010, what is the difference between the CO2 emissions (% of total fuel combustion) in Ethiopia and CO2 emissions (% of total fuel combustion) in Ghana?
Keep it short and to the point. 7.96. In the year 2010, what is the difference between the CO2 emissions (% of total fuel combustion) in Ethiopia and CO2 emissions (% of total fuel combustion) in Montenegro?
Ensure brevity in your answer.  13.93. In the year 2010, what is the difference between the CO2 emissions (% of total fuel combustion) in Ethiopia and CO2 emissions (% of total fuel combustion) in Zambia?
Make the answer very short. 10.9. In the year 2010, what is the difference between the CO2 emissions (% of total fuel combustion) of Ghana and CO2 emissions (% of total fuel combustion) of Montenegro?
Your answer should be very brief. 5.97. In the year 2010, what is the difference between the CO2 emissions (% of total fuel combustion) in Ghana and CO2 emissions (% of total fuel combustion) in Zambia?
Provide a short and direct response. 2.95. In the year 2010, what is the difference between the CO2 emissions (% of total fuel combustion) in Montenegro and CO2 emissions (% of total fuel combustion) in Zambia?
Keep it short and to the point. -3.03. In the year 2011, what is the difference between the CO2 emissions (% of total fuel combustion) in Ethiopia and CO2 emissions (% of total fuel combustion) in Ghana?
Your response must be concise. 5.8. In the year 2011, what is the difference between the CO2 emissions (% of total fuel combustion) of Ethiopia and CO2 emissions (% of total fuel combustion) of Montenegro?
Ensure brevity in your answer.  11.74. In the year 2011, what is the difference between the CO2 emissions (% of total fuel combustion) of Ethiopia and CO2 emissions (% of total fuel combustion) of Zambia?
Make the answer very short. 8.83. In the year 2011, what is the difference between the CO2 emissions (% of total fuel combustion) in Ghana and CO2 emissions (% of total fuel combustion) in Montenegro?
Keep it short and to the point. 5.95. In the year 2011, what is the difference between the CO2 emissions (% of total fuel combustion) of Ghana and CO2 emissions (% of total fuel combustion) of Zambia?
Ensure brevity in your answer.  3.03. In the year 2011, what is the difference between the CO2 emissions (% of total fuel combustion) in Montenegro and CO2 emissions (% of total fuel combustion) in Zambia?
Your answer should be compact. -2.92. What is the ratio of the CO2 emissions (% of total fuel combustion) of Ethiopia in 2005 to that in 2006?
Provide a short and direct response. 1.01. What is the ratio of the CO2 emissions (% of total fuel combustion) of Ghana in 2005 to that in 2006?
Make the answer very short. 1.29. What is the ratio of the CO2 emissions (% of total fuel combustion) of Montenegro in 2005 to that in 2006?
Your answer should be compact. 0.38. What is the ratio of the CO2 emissions (% of total fuel combustion) in Zambia in 2005 to that in 2006?
Ensure brevity in your answer.  2.67. What is the ratio of the CO2 emissions (% of total fuel combustion) in Ethiopia in 2005 to that in 2007?
Offer a very short reply. 1.03. What is the ratio of the CO2 emissions (% of total fuel combustion) in Ghana in 2005 to that in 2007?
Make the answer very short. 0.96. What is the ratio of the CO2 emissions (% of total fuel combustion) in Montenegro in 2005 to that in 2007?
Your answer should be very brief. 0.36. What is the ratio of the CO2 emissions (% of total fuel combustion) in Zambia in 2005 to that in 2007?
Make the answer very short. 2.38. What is the ratio of the CO2 emissions (% of total fuel combustion) of Ethiopia in 2005 to that in 2008?
Provide a short and direct response. 1.08. What is the ratio of the CO2 emissions (% of total fuel combustion) of Ghana in 2005 to that in 2008?
Give a very brief answer. 0.68. What is the ratio of the CO2 emissions (% of total fuel combustion) in Montenegro in 2005 to that in 2008?
Your answer should be very brief. 0.34. What is the ratio of the CO2 emissions (% of total fuel combustion) in Zambia in 2005 to that in 2008?
Provide a succinct answer. 2.16. What is the ratio of the CO2 emissions (% of total fuel combustion) in Ethiopia in 2005 to that in 2009?
Make the answer very short. 1.15. What is the ratio of the CO2 emissions (% of total fuel combustion) in Ghana in 2005 to that in 2009?
Provide a succinct answer. 0.93. What is the ratio of the CO2 emissions (% of total fuel combustion) of Montenegro in 2005 to that in 2009?
Ensure brevity in your answer.  0.44. What is the ratio of the CO2 emissions (% of total fuel combustion) in Zambia in 2005 to that in 2009?
Ensure brevity in your answer.  2.25. What is the ratio of the CO2 emissions (% of total fuel combustion) of Ethiopia in 2005 to that in 2010?
Give a very brief answer. 1.21. What is the ratio of the CO2 emissions (% of total fuel combustion) of Ghana in 2005 to that in 2010?
Give a very brief answer. 1.13. What is the ratio of the CO2 emissions (% of total fuel combustion) of Montenegro in 2005 to that in 2010?
Keep it short and to the point. 1.27. What is the ratio of the CO2 emissions (% of total fuel combustion) in Zambia in 2005 to that in 2010?
Give a very brief answer. 1.95. What is the ratio of the CO2 emissions (% of total fuel combustion) in Ethiopia in 2005 to that in 2011?
Offer a terse response. 1.43. What is the ratio of the CO2 emissions (% of total fuel combustion) in Ghana in 2005 to that in 2011?
Give a very brief answer. 1.14. What is the ratio of the CO2 emissions (% of total fuel combustion) of Montenegro in 2005 to that in 2011?
Keep it short and to the point. 1.28. What is the ratio of the CO2 emissions (% of total fuel combustion) of Zambia in 2005 to that in 2011?
Keep it short and to the point. 2.02. What is the ratio of the CO2 emissions (% of total fuel combustion) in Ethiopia in 2006 to that in 2007?
Offer a very short reply. 1.03. What is the ratio of the CO2 emissions (% of total fuel combustion) of Ghana in 2006 to that in 2007?
Make the answer very short. 0.74. What is the ratio of the CO2 emissions (% of total fuel combustion) in Montenegro in 2006 to that in 2007?
Provide a short and direct response. 0.94. What is the ratio of the CO2 emissions (% of total fuel combustion) in Zambia in 2006 to that in 2007?
Provide a succinct answer. 0.89. What is the ratio of the CO2 emissions (% of total fuel combustion) of Ethiopia in 2006 to that in 2008?
Your answer should be very brief. 1.07. What is the ratio of the CO2 emissions (% of total fuel combustion) in Ghana in 2006 to that in 2008?
Keep it short and to the point. 0.53. What is the ratio of the CO2 emissions (% of total fuel combustion) in Montenegro in 2006 to that in 2008?
Ensure brevity in your answer.  0.9. What is the ratio of the CO2 emissions (% of total fuel combustion) in Zambia in 2006 to that in 2008?
Provide a short and direct response. 0.81. What is the ratio of the CO2 emissions (% of total fuel combustion) in Ethiopia in 2006 to that in 2009?
Make the answer very short. 1.14. What is the ratio of the CO2 emissions (% of total fuel combustion) in Ghana in 2006 to that in 2009?
Offer a terse response. 0.73. What is the ratio of the CO2 emissions (% of total fuel combustion) of Montenegro in 2006 to that in 2009?
Your answer should be very brief. 1.15. What is the ratio of the CO2 emissions (% of total fuel combustion) in Zambia in 2006 to that in 2009?
Ensure brevity in your answer.  0.84. What is the ratio of the CO2 emissions (% of total fuel combustion) of Ethiopia in 2006 to that in 2010?
Your answer should be compact. 1.2. What is the ratio of the CO2 emissions (% of total fuel combustion) of Ghana in 2006 to that in 2010?
Keep it short and to the point. 0.88. What is the ratio of the CO2 emissions (% of total fuel combustion) of Montenegro in 2006 to that in 2010?
Provide a short and direct response. 3.35. What is the ratio of the CO2 emissions (% of total fuel combustion) of Zambia in 2006 to that in 2010?
Offer a terse response. 0.73. What is the ratio of the CO2 emissions (% of total fuel combustion) of Ethiopia in 2006 to that in 2011?
Your answer should be very brief. 1.42. What is the ratio of the CO2 emissions (% of total fuel combustion) in Ghana in 2006 to that in 2011?
Your answer should be very brief. 0.88. What is the ratio of the CO2 emissions (% of total fuel combustion) of Montenegro in 2006 to that in 2011?
Ensure brevity in your answer.  3.38. What is the ratio of the CO2 emissions (% of total fuel combustion) in Zambia in 2006 to that in 2011?
Offer a very short reply. 0.76. What is the ratio of the CO2 emissions (% of total fuel combustion) of Ethiopia in 2007 to that in 2008?
Offer a very short reply. 1.04. What is the ratio of the CO2 emissions (% of total fuel combustion) of Ghana in 2007 to that in 2008?
Offer a very short reply. 0.71. What is the ratio of the CO2 emissions (% of total fuel combustion) in Montenegro in 2007 to that in 2008?
Keep it short and to the point. 0.96. What is the ratio of the CO2 emissions (% of total fuel combustion) in Zambia in 2007 to that in 2008?
Your answer should be very brief. 0.91. What is the ratio of the CO2 emissions (% of total fuel combustion) of Ethiopia in 2007 to that in 2009?
Offer a terse response. 1.11. What is the ratio of the CO2 emissions (% of total fuel combustion) in Ghana in 2007 to that in 2009?
Your response must be concise. 0.98. What is the ratio of the CO2 emissions (% of total fuel combustion) of Montenegro in 2007 to that in 2009?
Keep it short and to the point. 1.23. What is the ratio of the CO2 emissions (% of total fuel combustion) of Zambia in 2007 to that in 2009?
Provide a succinct answer. 0.95. What is the ratio of the CO2 emissions (% of total fuel combustion) in Ethiopia in 2007 to that in 2010?
Offer a terse response. 1.17. What is the ratio of the CO2 emissions (% of total fuel combustion) of Ghana in 2007 to that in 2010?
Ensure brevity in your answer.  1.18. What is the ratio of the CO2 emissions (% of total fuel combustion) in Montenegro in 2007 to that in 2010?
Provide a short and direct response. 3.58. What is the ratio of the CO2 emissions (% of total fuel combustion) of Zambia in 2007 to that in 2010?
Provide a short and direct response. 0.82. What is the ratio of the CO2 emissions (% of total fuel combustion) of Ethiopia in 2007 to that in 2011?
Your answer should be very brief. 1.39. What is the ratio of the CO2 emissions (% of total fuel combustion) in Ghana in 2007 to that in 2011?
Your response must be concise. 1.19. What is the ratio of the CO2 emissions (% of total fuel combustion) of Montenegro in 2007 to that in 2011?
Offer a terse response. 3.61. What is the ratio of the CO2 emissions (% of total fuel combustion) in Zambia in 2007 to that in 2011?
Provide a short and direct response. 0.85. What is the ratio of the CO2 emissions (% of total fuel combustion) of Ethiopia in 2008 to that in 2009?
Your answer should be very brief. 1.06. What is the ratio of the CO2 emissions (% of total fuel combustion) in Ghana in 2008 to that in 2009?
Offer a very short reply. 1.38. What is the ratio of the CO2 emissions (% of total fuel combustion) of Montenegro in 2008 to that in 2009?
Offer a very short reply. 1.27. What is the ratio of the CO2 emissions (% of total fuel combustion) in Zambia in 2008 to that in 2009?
Ensure brevity in your answer.  1.04. What is the ratio of the CO2 emissions (% of total fuel combustion) in Ethiopia in 2008 to that in 2010?
Offer a very short reply. 1.13. What is the ratio of the CO2 emissions (% of total fuel combustion) in Ghana in 2008 to that in 2010?
Ensure brevity in your answer.  1.68. What is the ratio of the CO2 emissions (% of total fuel combustion) of Montenegro in 2008 to that in 2010?
Make the answer very short. 3.72. What is the ratio of the CO2 emissions (% of total fuel combustion) in Zambia in 2008 to that in 2010?
Your answer should be compact. 0.91. What is the ratio of the CO2 emissions (% of total fuel combustion) of Ethiopia in 2008 to that in 2011?
Keep it short and to the point. 1.33. What is the ratio of the CO2 emissions (% of total fuel combustion) of Ghana in 2008 to that in 2011?
Make the answer very short. 1.68. What is the ratio of the CO2 emissions (% of total fuel combustion) in Montenegro in 2008 to that in 2011?
Give a very brief answer. 3.75. What is the ratio of the CO2 emissions (% of total fuel combustion) of Zambia in 2008 to that in 2011?
Ensure brevity in your answer.  0.94. What is the ratio of the CO2 emissions (% of total fuel combustion) in Ethiopia in 2009 to that in 2010?
Provide a succinct answer. 1.06. What is the ratio of the CO2 emissions (% of total fuel combustion) of Ghana in 2009 to that in 2010?
Provide a succinct answer. 1.21. What is the ratio of the CO2 emissions (% of total fuel combustion) of Montenegro in 2009 to that in 2010?
Your answer should be very brief. 2.92. What is the ratio of the CO2 emissions (% of total fuel combustion) of Zambia in 2009 to that in 2010?
Make the answer very short. 0.87. What is the ratio of the CO2 emissions (% of total fuel combustion) in Ethiopia in 2009 to that in 2011?
Your answer should be very brief. 1.25. What is the ratio of the CO2 emissions (% of total fuel combustion) of Ghana in 2009 to that in 2011?
Provide a short and direct response. 1.22. What is the ratio of the CO2 emissions (% of total fuel combustion) of Montenegro in 2009 to that in 2011?
Give a very brief answer. 2.94. What is the ratio of the CO2 emissions (% of total fuel combustion) of Zambia in 2009 to that in 2011?
Ensure brevity in your answer.  0.9. What is the ratio of the CO2 emissions (% of total fuel combustion) of Ethiopia in 2010 to that in 2011?
Your answer should be compact. 1.18. What is the ratio of the CO2 emissions (% of total fuel combustion) of Ghana in 2010 to that in 2011?
Your answer should be compact. 1. What is the ratio of the CO2 emissions (% of total fuel combustion) of Montenegro in 2010 to that in 2011?
Ensure brevity in your answer.  1.01. What is the ratio of the CO2 emissions (% of total fuel combustion) in Zambia in 2010 to that in 2011?
Offer a terse response. 1.03. What is the difference between the highest and the second highest CO2 emissions (% of total fuel combustion) in Ethiopia?
Give a very brief answer. 0.11. What is the difference between the highest and the second highest CO2 emissions (% of total fuel combustion) of Ghana?
Give a very brief answer. 2.96. What is the difference between the highest and the second highest CO2 emissions (% of total fuel combustion) in Montenegro?
Your response must be concise. 0.06. What is the difference between the highest and the second highest CO2 emissions (% of total fuel combustion) of Zambia?
Offer a very short reply. 3.27. What is the difference between the highest and the lowest CO2 emissions (% of total fuel combustion) in Ethiopia?
Make the answer very short. 5.22. What is the difference between the highest and the lowest CO2 emissions (% of total fuel combustion) of Ghana?
Keep it short and to the point. 5.07. What is the difference between the highest and the lowest CO2 emissions (% of total fuel combustion) of Montenegro?
Ensure brevity in your answer.  1.1. What is the difference between the highest and the lowest CO2 emissions (% of total fuel combustion) of Zambia?
Offer a very short reply. 4.19. 